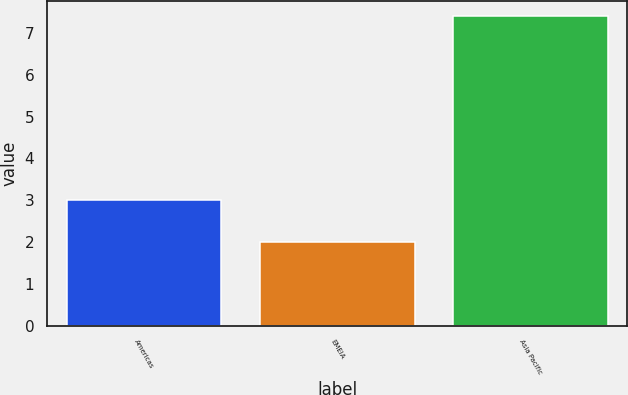Convert chart to OTSL. <chart><loc_0><loc_0><loc_500><loc_500><bar_chart><fcel>Americas<fcel>EMEIA<fcel>Asia Pacific<nl><fcel>3<fcel>2<fcel>7.4<nl></chart> 